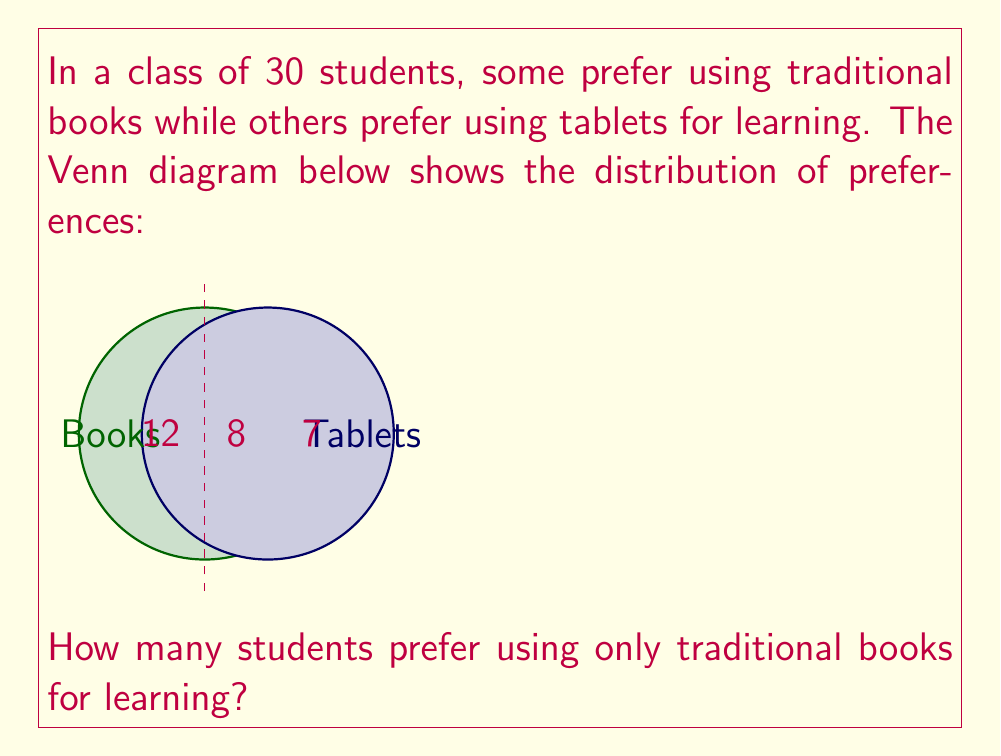Can you solve this math problem? Let's approach this step-by-step:

1) First, let's understand what the Venn diagram represents:
   - The left circle represents students who prefer books
   - The right circle represents students who prefer tablets
   - The overlapping region represents students who prefer both

2) We can see that:
   - 12 students prefer only books
   - 8 students prefer both books and tablets
   - 7 students prefer only tablets

3) To find the number of students who prefer only traditional books, we simply need to look at the number in the left circle that doesn't overlap with the tablet circle.

4) This number is given directly in the diagram: 12

5) We can verify this by adding up all the numbers:
   $12 + 8 + 7 = 27$

   This is less than the total class size (30), which makes sense as there might be students who prefer neither books nor tablets.

Therefore, 12 students prefer using only traditional books for learning.
Answer: 12 